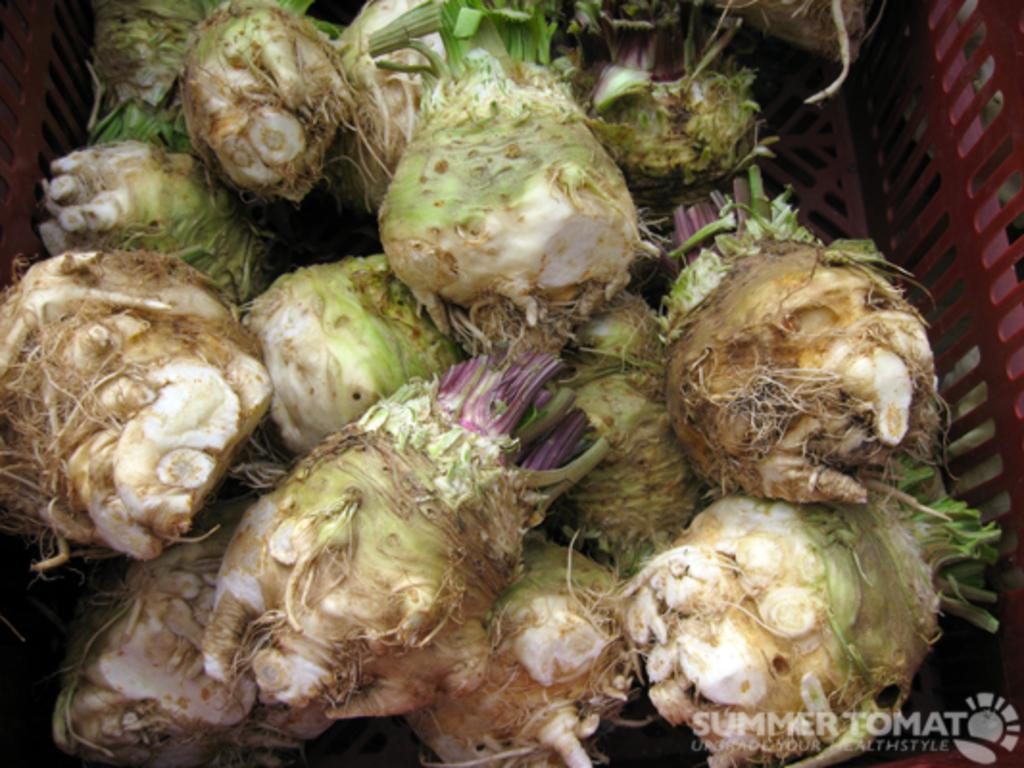What is the color of the basket in the image? The basket in the image is red. What is inside the basket? The basket contains vegetables. Are there any paper planes flying around the basket in the image? No, there are no paper planes or any planes visible in the image. 